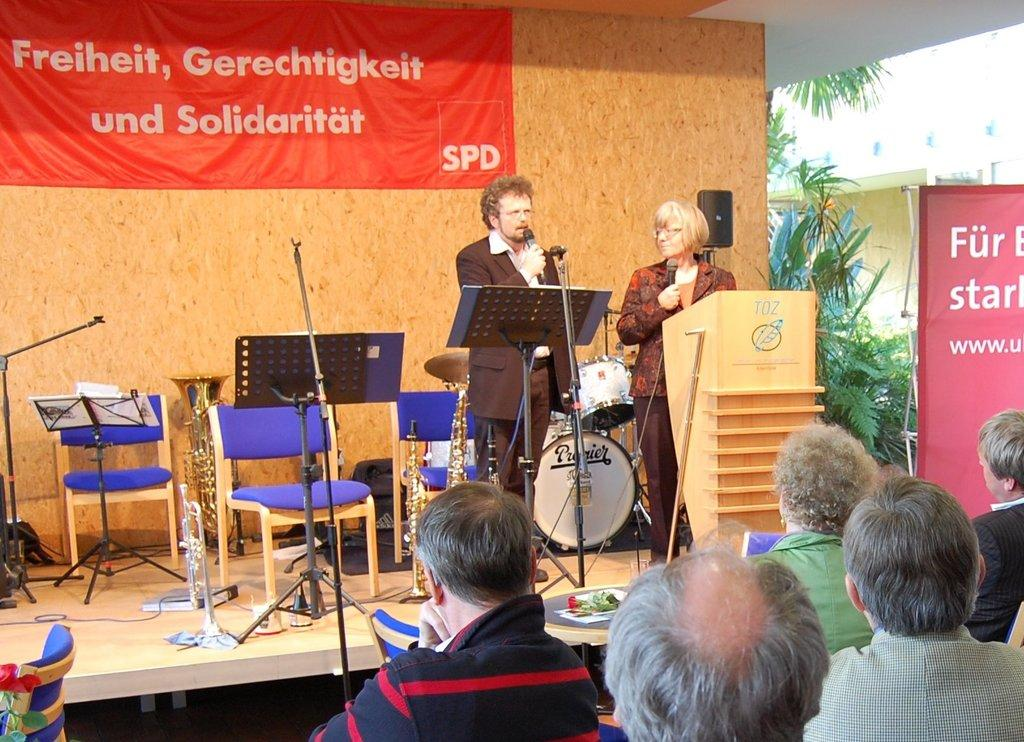How many people are in the image? There are people in the image, but the exact number is not specified. What are the two people holding in the image? The two people are standing and holding microphones. What object can be seen in the image that is often used for speeches or presentations? There is a podium in the image. What other items are present in the image that are related to music or performance? There are musical instruments in the image. What type of furniture is present in the image for seating? There are chairs in the image. Can you see a maid cleaning the seashore in the image? No, there is no maid or seashore present in the image. 